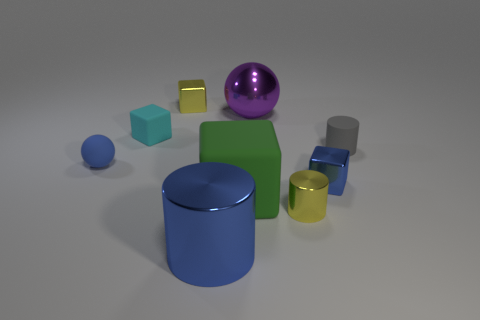Subtract all blue cubes. Subtract all gray spheres. How many cubes are left? 3 Subtract all brown spheres. How many gray cylinders are left? 1 Add 5 greens. How many purples exist? 0 Subtract all tiny yellow rubber cylinders. Subtract all blue rubber things. How many objects are left? 8 Add 3 large green rubber objects. How many large green rubber objects are left? 4 Add 7 large metallic cylinders. How many large metallic cylinders exist? 8 Add 1 big matte things. How many objects exist? 10 Subtract all yellow cylinders. How many cylinders are left? 2 Subtract all small blocks. How many blocks are left? 1 Subtract 1 green cubes. How many objects are left? 8 